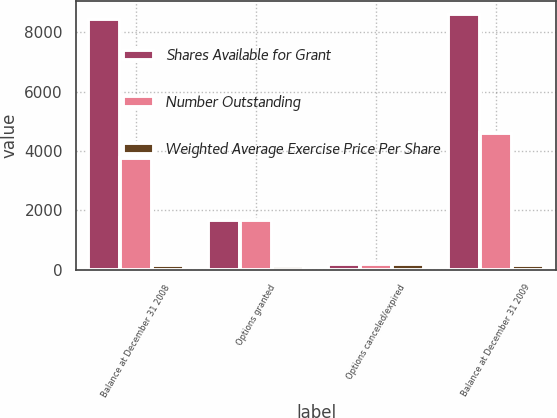Convert chart to OTSL. <chart><loc_0><loc_0><loc_500><loc_500><stacked_bar_chart><ecel><fcel>Balance at December 31 2008<fcel>Options granted<fcel>Options canceled/expired<fcel>Balance at December 31 2009<nl><fcel>Shares Available for Grant<fcel>8449<fcel>1662<fcel>187<fcel>8622<nl><fcel>Number Outstanding<fcel>3749<fcel>1662<fcel>187<fcel>4593<nl><fcel>Weighted Average Exercise Price Per Share<fcel>163.25<fcel>122.31<fcel>203.07<fcel>157.25<nl></chart> 